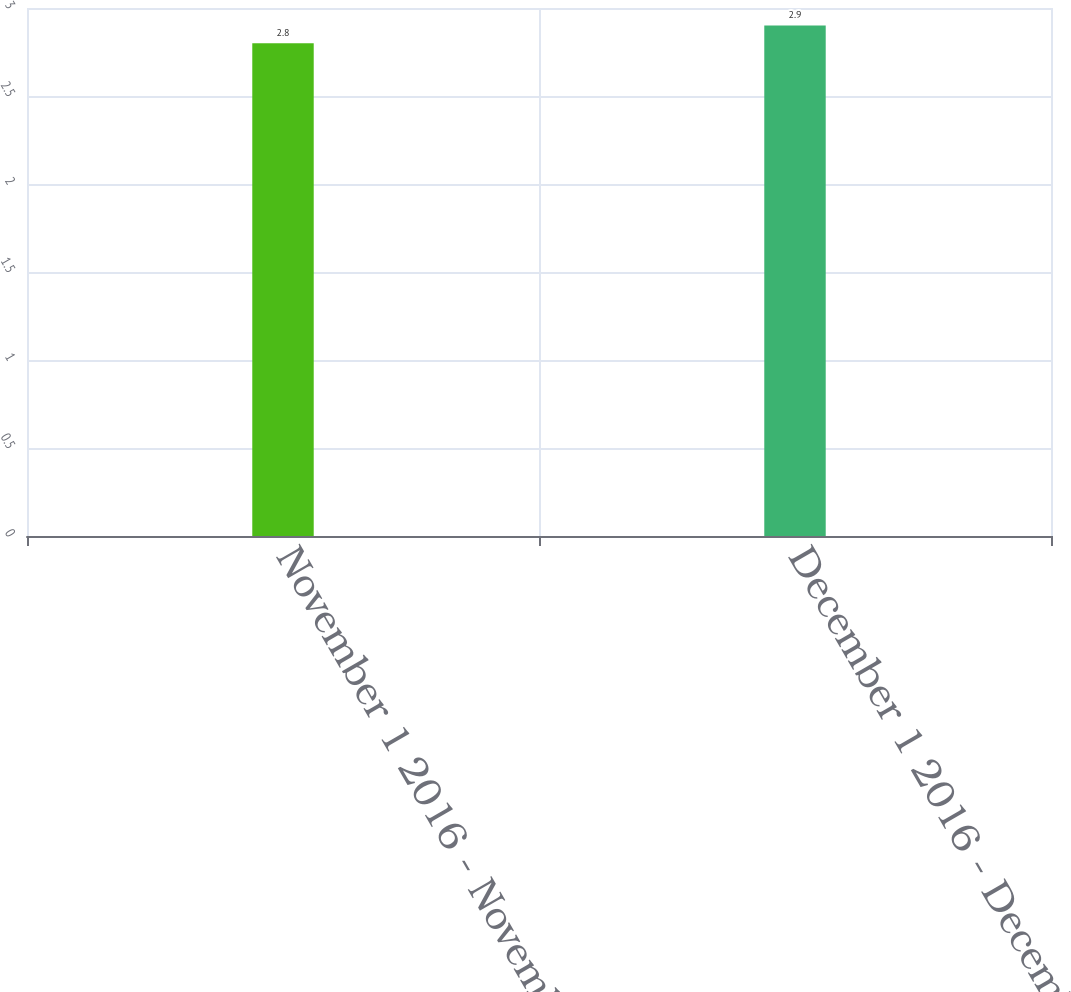<chart> <loc_0><loc_0><loc_500><loc_500><bar_chart><fcel>November 1 2016 - November 30<fcel>December 1 2016 - December 31<nl><fcel>2.8<fcel>2.9<nl></chart> 